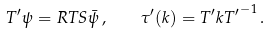<formula> <loc_0><loc_0><loc_500><loc_500>T ^ { \prime } \psi = R T S \bar { \psi } \, , \quad \tau ^ { \prime } ( k ) = T ^ { \prime } k { T ^ { \prime } } ^ { - 1 } \, .</formula> 